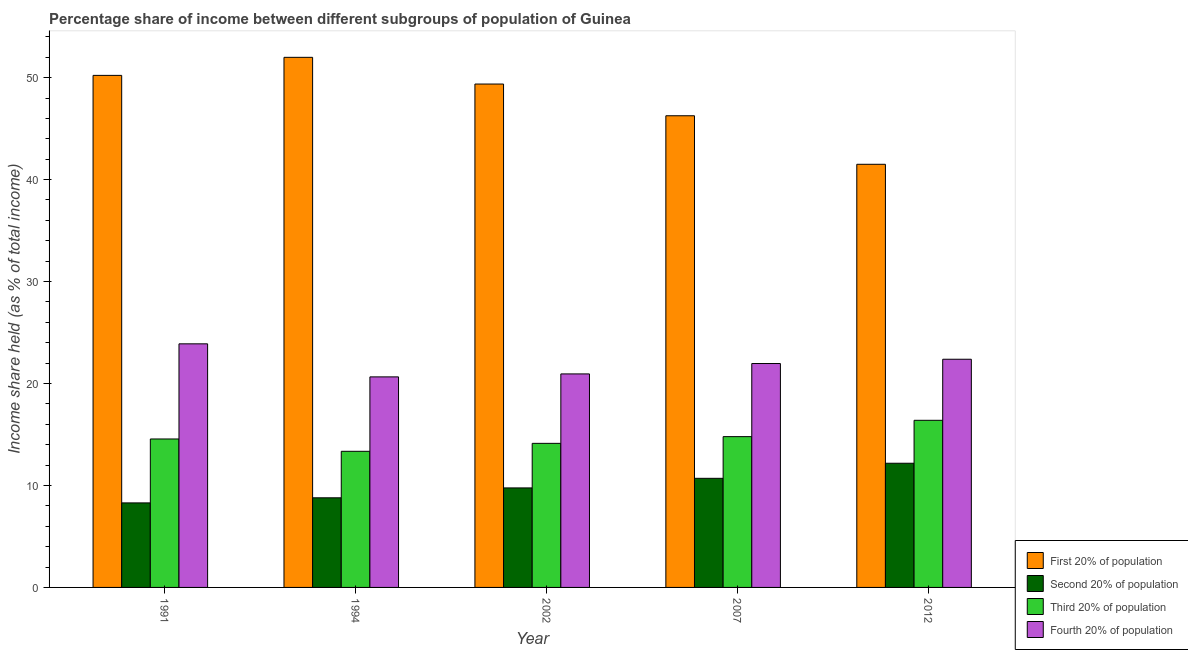How many groups of bars are there?
Provide a short and direct response. 5. Are the number of bars per tick equal to the number of legend labels?
Give a very brief answer. Yes. Are the number of bars on each tick of the X-axis equal?
Offer a terse response. Yes. How many bars are there on the 5th tick from the left?
Make the answer very short. 4. How many bars are there on the 3rd tick from the right?
Make the answer very short. 4. In how many cases, is the number of bars for a given year not equal to the number of legend labels?
Provide a short and direct response. 0. What is the share of the income held by third 20% of the population in 1994?
Provide a short and direct response. 13.35. Across all years, what is the maximum share of the income held by second 20% of the population?
Offer a very short reply. 12.18. Across all years, what is the minimum share of the income held by first 20% of the population?
Offer a terse response. 41.5. What is the total share of the income held by second 20% of the population in the graph?
Your answer should be compact. 49.72. What is the difference between the share of the income held by first 20% of the population in 1991 and that in 2007?
Your response must be concise. 3.96. What is the difference between the share of the income held by fourth 20% of the population in 2012 and the share of the income held by third 20% of the population in 2002?
Offer a terse response. 1.44. What is the average share of the income held by fourth 20% of the population per year?
Provide a short and direct response. 21.96. In how many years, is the share of the income held by first 20% of the population greater than 36 %?
Your answer should be compact. 5. What is the ratio of the share of the income held by fourth 20% of the population in 1994 to that in 2007?
Your response must be concise. 0.94. Is the share of the income held by first 20% of the population in 2002 less than that in 2012?
Make the answer very short. No. Is the difference between the share of the income held by first 20% of the population in 1994 and 2007 greater than the difference between the share of the income held by fourth 20% of the population in 1994 and 2007?
Give a very brief answer. No. What is the difference between the highest and the second highest share of the income held by second 20% of the population?
Ensure brevity in your answer.  1.48. What is the difference between the highest and the lowest share of the income held by fourth 20% of the population?
Make the answer very short. 3.24. Is it the case that in every year, the sum of the share of the income held by second 20% of the population and share of the income held by fourth 20% of the population is greater than the sum of share of the income held by first 20% of the population and share of the income held by third 20% of the population?
Offer a terse response. No. What does the 4th bar from the left in 1994 represents?
Keep it short and to the point. Fourth 20% of population. What does the 3rd bar from the right in 2002 represents?
Make the answer very short. Second 20% of population. How many years are there in the graph?
Ensure brevity in your answer.  5. What is the difference between two consecutive major ticks on the Y-axis?
Your answer should be very brief. 10. Are the values on the major ticks of Y-axis written in scientific E-notation?
Keep it short and to the point. No. Where does the legend appear in the graph?
Your response must be concise. Bottom right. How many legend labels are there?
Your answer should be very brief. 4. What is the title of the graph?
Give a very brief answer. Percentage share of income between different subgroups of population of Guinea. Does "HFC gas" appear as one of the legend labels in the graph?
Your answer should be very brief. No. What is the label or title of the X-axis?
Your answer should be very brief. Year. What is the label or title of the Y-axis?
Keep it short and to the point. Income share held (as % of total income). What is the Income share held (as % of total income) of First 20% of population in 1991?
Ensure brevity in your answer.  50.22. What is the Income share held (as % of total income) of Second 20% of population in 1991?
Keep it short and to the point. 8.29. What is the Income share held (as % of total income) of Third 20% of population in 1991?
Offer a terse response. 14.56. What is the Income share held (as % of total income) in Fourth 20% of population in 1991?
Your response must be concise. 23.89. What is the Income share held (as % of total income) in First 20% of population in 1994?
Offer a terse response. 51.99. What is the Income share held (as % of total income) in Second 20% of population in 1994?
Make the answer very short. 8.79. What is the Income share held (as % of total income) in Third 20% of population in 1994?
Ensure brevity in your answer.  13.35. What is the Income share held (as % of total income) in Fourth 20% of population in 1994?
Give a very brief answer. 20.65. What is the Income share held (as % of total income) of First 20% of population in 2002?
Ensure brevity in your answer.  49.37. What is the Income share held (as % of total income) of Second 20% of population in 2002?
Provide a short and direct response. 9.76. What is the Income share held (as % of total income) in Third 20% of population in 2002?
Ensure brevity in your answer.  14.13. What is the Income share held (as % of total income) in Fourth 20% of population in 2002?
Make the answer very short. 20.94. What is the Income share held (as % of total income) in First 20% of population in 2007?
Your response must be concise. 46.26. What is the Income share held (as % of total income) in Third 20% of population in 2007?
Provide a short and direct response. 14.79. What is the Income share held (as % of total income) of Fourth 20% of population in 2007?
Keep it short and to the point. 21.96. What is the Income share held (as % of total income) of First 20% of population in 2012?
Your response must be concise. 41.5. What is the Income share held (as % of total income) in Second 20% of population in 2012?
Your answer should be compact. 12.18. What is the Income share held (as % of total income) of Third 20% of population in 2012?
Your answer should be compact. 16.39. What is the Income share held (as % of total income) of Fourth 20% of population in 2012?
Ensure brevity in your answer.  22.38. Across all years, what is the maximum Income share held (as % of total income) of First 20% of population?
Keep it short and to the point. 51.99. Across all years, what is the maximum Income share held (as % of total income) in Second 20% of population?
Your answer should be compact. 12.18. Across all years, what is the maximum Income share held (as % of total income) in Third 20% of population?
Your answer should be very brief. 16.39. Across all years, what is the maximum Income share held (as % of total income) of Fourth 20% of population?
Your response must be concise. 23.89. Across all years, what is the minimum Income share held (as % of total income) in First 20% of population?
Your answer should be compact. 41.5. Across all years, what is the minimum Income share held (as % of total income) in Second 20% of population?
Ensure brevity in your answer.  8.29. Across all years, what is the minimum Income share held (as % of total income) of Third 20% of population?
Provide a short and direct response. 13.35. Across all years, what is the minimum Income share held (as % of total income) of Fourth 20% of population?
Make the answer very short. 20.65. What is the total Income share held (as % of total income) in First 20% of population in the graph?
Your answer should be compact. 239.34. What is the total Income share held (as % of total income) of Second 20% of population in the graph?
Your answer should be compact. 49.72. What is the total Income share held (as % of total income) of Third 20% of population in the graph?
Keep it short and to the point. 73.22. What is the total Income share held (as % of total income) of Fourth 20% of population in the graph?
Your response must be concise. 109.82. What is the difference between the Income share held (as % of total income) in First 20% of population in 1991 and that in 1994?
Make the answer very short. -1.77. What is the difference between the Income share held (as % of total income) in Third 20% of population in 1991 and that in 1994?
Keep it short and to the point. 1.21. What is the difference between the Income share held (as % of total income) in Fourth 20% of population in 1991 and that in 1994?
Your answer should be compact. 3.24. What is the difference between the Income share held (as % of total income) in Second 20% of population in 1991 and that in 2002?
Offer a terse response. -1.47. What is the difference between the Income share held (as % of total income) of Third 20% of population in 1991 and that in 2002?
Your answer should be compact. 0.43. What is the difference between the Income share held (as % of total income) in Fourth 20% of population in 1991 and that in 2002?
Provide a short and direct response. 2.95. What is the difference between the Income share held (as % of total income) of First 20% of population in 1991 and that in 2007?
Your answer should be compact. 3.96. What is the difference between the Income share held (as % of total income) of Second 20% of population in 1991 and that in 2007?
Provide a short and direct response. -2.41. What is the difference between the Income share held (as % of total income) in Third 20% of population in 1991 and that in 2007?
Make the answer very short. -0.23. What is the difference between the Income share held (as % of total income) of Fourth 20% of population in 1991 and that in 2007?
Give a very brief answer. 1.93. What is the difference between the Income share held (as % of total income) of First 20% of population in 1991 and that in 2012?
Your response must be concise. 8.72. What is the difference between the Income share held (as % of total income) of Second 20% of population in 1991 and that in 2012?
Your answer should be compact. -3.89. What is the difference between the Income share held (as % of total income) in Third 20% of population in 1991 and that in 2012?
Your answer should be very brief. -1.83. What is the difference between the Income share held (as % of total income) of Fourth 20% of population in 1991 and that in 2012?
Provide a succinct answer. 1.51. What is the difference between the Income share held (as % of total income) in First 20% of population in 1994 and that in 2002?
Provide a short and direct response. 2.62. What is the difference between the Income share held (as % of total income) in Second 20% of population in 1994 and that in 2002?
Your answer should be compact. -0.97. What is the difference between the Income share held (as % of total income) of Third 20% of population in 1994 and that in 2002?
Offer a very short reply. -0.78. What is the difference between the Income share held (as % of total income) of Fourth 20% of population in 1994 and that in 2002?
Your response must be concise. -0.29. What is the difference between the Income share held (as % of total income) in First 20% of population in 1994 and that in 2007?
Make the answer very short. 5.73. What is the difference between the Income share held (as % of total income) of Second 20% of population in 1994 and that in 2007?
Your answer should be compact. -1.91. What is the difference between the Income share held (as % of total income) in Third 20% of population in 1994 and that in 2007?
Your answer should be compact. -1.44. What is the difference between the Income share held (as % of total income) of Fourth 20% of population in 1994 and that in 2007?
Provide a succinct answer. -1.31. What is the difference between the Income share held (as % of total income) in First 20% of population in 1994 and that in 2012?
Offer a very short reply. 10.49. What is the difference between the Income share held (as % of total income) in Second 20% of population in 1994 and that in 2012?
Offer a very short reply. -3.39. What is the difference between the Income share held (as % of total income) of Third 20% of population in 1994 and that in 2012?
Keep it short and to the point. -3.04. What is the difference between the Income share held (as % of total income) of Fourth 20% of population in 1994 and that in 2012?
Your answer should be compact. -1.73. What is the difference between the Income share held (as % of total income) in First 20% of population in 2002 and that in 2007?
Offer a terse response. 3.11. What is the difference between the Income share held (as % of total income) of Second 20% of population in 2002 and that in 2007?
Ensure brevity in your answer.  -0.94. What is the difference between the Income share held (as % of total income) of Third 20% of population in 2002 and that in 2007?
Provide a short and direct response. -0.66. What is the difference between the Income share held (as % of total income) in Fourth 20% of population in 2002 and that in 2007?
Give a very brief answer. -1.02. What is the difference between the Income share held (as % of total income) of First 20% of population in 2002 and that in 2012?
Your answer should be compact. 7.87. What is the difference between the Income share held (as % of total income) of Second 20% of population in 2002 and that in 2012?
Offer a very short reply. -2.42. What is the difference between the Income share held (as % of total income) of Third 20% of population in 2002 and that in 2012?
Your answer should be compact. -2.26. What is the difference between the Income share held (as % of total income) of Fourth 20% of population in 2002 and that in 2012?
Provide a succinct answer. -1.44. What is the difference between the Income share held (as % of total income) in First 20% of population in 2007 and that in 2012?
Provide a succinct answer. 4.76. What is the difference between the Income share held (as % of total income) of Second 20% of population in 2007 and that in 2012?
Make the answer very short. -1.48. What is the difference between the Income share held (as % of total income) in Third 20% of population in 2007 and that in 2012?
Give a very brief answer. -1.6. What is the difference between the Income share held (as % of total income) of Fourth 20% of population in 2007 and that in 2012?
Make the answer very short. -0.42. What is the difference between the Income share held (as % of total income) of First 20% of population in 1991 and the Income share held (as % of total income) of Second 20% of population in 1994?
Keep it short and to the point. 41.43. What is the difference between the Income share held (as % of total income) in First 20% of population in 1991 and the Income share held (as % of total income) in Third 20% of population in 1994?
Make the answer very short. 36.87. What is the difference between the Income share held (as % of total income) of First 20% of population in 1991 and the Income share held (as % of total income) of Fourth 20% of population in 1994?
Provide a short and direct response. 29.57. What is the difference between the Income share held (as % of total income) of Second 20% of population in 1991 and the Income share held (as % of total income) of Third 20% of population in 1994?
Your answer should be compact. -5.06. What is the difference between the Income share held (as % of total income) in Second 20% of population in 1991 and the Income share held (as % of total income) in Fourth 20% of population in 1994?
Offer a terse response. -12.36. What is the difference between the Income share held (as % of total income) in Third 20% of population in 1991 and the Income share held (as % of total income) in Fourth 20% of population in 1994?
Your answer should be very brief. -6.09. What is the difference between the Income share held (as % of total income) in First 20% of population in 1991 and the Income share held (as % of total income) in Second 20% of population in 2002?
Your response must be concise. 40.46. What is the difference between the Income share held (as % of total income) in First 20% of population in 1991 and the Income share held (as % of total income) in Third 20% of population in 2002?
Offer a very short reply. 36.09. What is the difference between the Income share held (as % of total income) of First 20% of population in 1991 and the Income share held (as % of total income) of Fourth 20% of population in 2002?
Ensure brevity in your answer.  29.28. What is the difference between the Income share held (as % of total income) of Second 20% of population in 1991 and the Income share held (as % of total income) of Third 20% of population in 2002?
Offer a terse response. -5.84. What is the difference between the Income share held (as % of total income) in Second 20% of population in 1991 and the Income share held (as % of total income) in Fourth 20% of population in 2002?
Provide a short and direct response. -12.65. What is the difference between the Income share held (as % of total income) of Third 20% of population in 1991 and the Income share held (as % of total income) of Fourth 20% of population in 2002?
Offer a very short reply. -6.38. What is the difference between the Income share held (as % of total income) in First 20% of population in 1991 and the Income share held (as % of total income) in Second 20% of population in 2007?
Offer a terse response. 39.52. What is the difference between the Income share held (as % of total income) of First 20% of population in 1991 and the Income share held (as % of total income) of Third 20% of population in 2007?
Your answer should be very brief. 35.43. What is the difference between the Income share held (as % of total income) of First 20% of population in 1991 and the Income share held (as % of total income) of Fourth 20% of population in 2007?
Your answer should be compact. 28.26. What is the difference between the Income share held (as % of total income) of Second 20% of population in 1991 and the Income share held (as % of total income) of Fourth 20% of population in 2007?
Offer a very short reply. -13.67. What is the difference between the Income share held (as % of total income) of Third 20% of population in 1991 and the Income share held (as % of total income) of Fourth 20% of population in 2007?
Ensure brevity in your answer.  -7.4. What is the difference between the Income share held (as % of total income) in First 20% of population in 1991 and the Income share held (as % of total income) in Second 20% of population in 2012?
Make the answer very short. 38.04. What is the difference between the Income share held (as % of total income) in First 20% of population in 1991 and the Income share held (as % of total income) in Third 20% of population in 2012?
Keep it short and to the point. 33.83. What is the difference between the Income share held (as % of total income) of First 20% of population in 1991 and the Income share held (as % of total income) of Fourth 20% of population in 2012?
Give a very brief answer. 27.84. What is the difference between the Income share held (as % of total income) of Second 20% of population in 1991 and the Income share held (as % of total income) of Third 20% of population in 2012?
Ensure brevity in your answer.  -8.1. What is the difference between the Income share held (as % of total income) of Second 20% of population in 1991 and the Income share held (as % of total income) of Fourth 20% of population in 2012?
Keep it short and to the point. -14.09. What is the difference between the Income share held (as % of total income) in Third 20% of population in 1991 and the Income share held (as % of total income) in Fourth 20% of population in 2012?
Give a very brief answer. -7.82. What is the difference between the Income share held (as % of total income) in First 20% of population in 1994 and the Income share held (as % of total income) in Second 20% of population in 2002?
Keep it short and to the point. 42.23. What is the difference between the Income share held (as % of total income) in First 20% of population in 1994 and the Income share held (as % of total income) in Third 20% of population in 2002?
Your response must be concise. 37.86. What is the difference between the Income share held (as % of total income) in First 20% of population in 1994 and the Income share held (as % of total income) in Fourth 20% of population in 2002?
Your answer should be very brief. 31.05. What is the difference between the Income share held (as % of total income) in Second 20% of population in 1994 and the Income share held (as % of total income) in Third 20% of population in 2002?
Provide a succinct answer. -5.34. What is the difference between the Income share held (as % of total income) in Second 20% of population in 1994 and the Income share held (as % of total income) in Fourth 20% of population in 2002?
Offer a terse response. -12.15. What is the difference between the Income share held (as % of total income) of Third 20% of population in 1994 and the Income share held (as % of total income) of Fourth 20% of population in 2002?
Keep it short and to the point. -7.59. What is the difference between the Income share held (as % of total income) in First 20% of population in 1994 and the Income share held (as % of total income) in Second 20% of population in 2007?
Offer a terse response. 41.29. What is the difference between the Income share held (as % of total income) in First 20% of population in 1994 and the Income share held (as % of total income) in Third 20% of population in 2007?
Give a very brief answer. 37.2. What is the difference between the Income share held (as % of total income) in First 20% of population in 1994 and the Income share held (as % of total income) in Fourth 20% of population in 2007?
Your response must be concise. 30.03. What is the difference between the Income share held (as % of total income) in Second 20% of population in 1994 and the Income share held (as % of total income) in Fourth 20% of population in 2007?
Your answer should be compact. -13.17. What is the difference between the Income share held (as % of total income) in Third 20% of population in 1994 and the Income share held (as % of total income) in Fourth 20% of population in 2007?
Provide a short and direct response. -8.61. What is the difference between the Income share held (as % of total income) in First 20% of population in 1994 and the Income share held (as % of total income) in Second 20% of population in 2012?
Ensure brevity in your answer.  39.81. What is the difference between the Income share held (as % of total income) in First 20% of population in 1994 and the Income share held (as % of total income) in Third 20% of population in 2012?
Offer a terse response. 35.6. What is the difference between the Income share held (as % of total income) in First 20% of population in 1994 and the Income share held (as % of total income) in Fourth 20% of population in 2012?
Your answer should be very brief. 29.61. What is the difference between the Income share held (as % of total income) of Second 20% of population in 1994 and the Income share held (as % of total income) of Third 20% of population in 2012?
Keep it short and to the point. -7.6. What is the difference between the Income share held (as % of total income) of Second 20% of population in 1994 and the Income share held (as % of total income) of Fourth 20% of population in 2012?
Offer a very short reply. -13.59. What is the difference between the Income share held (as % of total income) in Third 20% of population in 1994 and the Income share held (as % of total income) in Fourth 20% of population in 2012?
Your answer should be very brief. -9.03. What is the difference between the Income share held (as % of total income) in First 20% of population in 2002 and the Income share held (as % of total income) in Second 20% of population in 2007?
Keep it short and to the point. 38.67. What is the difference between the Income share held (as % of total income) of First 20% of population in 2002 and the Income share held (as % of total income) of Third 20% of population in 2007?
Offer a very short reply. 34.58. What is the difference between the Income share held (as % of total income) of First 20% of population in 2002 and the Income share held (as % of total income) of Fourth 20% of population in 2007?
Offer a terse response. 27.41. What is the difference between the Income share held (as % of total income) of Second 20% of population in 2002 and the Income share held (as % of total income) of Third 20% of population in 2007?
Make the answer very short. -5.03. What is the difference between the Income share held (as % of total income) in Third 20% of population in 2002 and the Income share held (as % of total income) in Fourth 20% of population in 2007?
Offer a terse response. -7.83. What is the difference between the Income share held (as % of total income) of First 20% of population in 2002 and the Income share held (as % of total income) of Second 20% of population in 2012?
Offer a very short reply. 37.19. What is the difference between the Income share held (as % of total income) in First 20% of population in 2002 and the Income share held (as % of total income) in Third 20% of population in 2012?
Your answer should be compact. 32.98. What is the difference between the Income share held (as % of total income) of First 20% of population in 2002 and the Income share held (as % of total income) of Fourth 20% of population in 2012?
Provide a succinct answer. 26.99. What is the difference between the Income share held (as % of total income) of Second 20% of population in 2002 and the Income share held (as % of total income) of Third 20% of population in 2012?
Make the answer very short. -6.63. What is the difference between the Income share held (as % of total income) of Second 20% of population in 2002 and the Income share held (as % of total income) of Fourth 20% of population in 2012?
Provide a short and direct response. -12.62. What is the difference between the Income share held (as % of total income) of Third 20% of population in 2002 and the Income share held (as % of total income) of Fourth 20% of population in 2012?
Offer a terse response. -8.25. What is the difference between the Income share held (as % of total income) of First 20% of population in 2007 and the Income share held (as % of total income) of Second 20% of population in 2012?
Ensure brevity in your answer.  34.08. What is the difference between the Income share held (as % of total income) of First 20% of population in 2007 and the Income share held (as % of total income) of Third 20% of population in 2012?
Your response must be concise. 29.87. What is the difference between the Income share held (as % of total income) in First 20% of population in 2007 and the Income share held (as % of total income) in Fourth 20% of population in 2012?
Keep it short and to the point. 23.88. What is the difference between the Income share held (as % of total income) in Second 20% of population in 2007 and the Income share held (as % of total income) in Third 20% of population in 2012?
Provide a short and direct response. -5.69. What is the difference between the Income share held (as % of total income) of Second 20% of population in 2007 and the Income share held (as % of total income) of Fourth 20% of population in 2012?
Provide a short and direct response. -11.68. What is the difference between the Income share held (as % of total income) of Third 20% of population in 2007 and the Income share held (as % of total income) of Fourth 20% of population in 2012?
Make the answer very short. -7.59. What is the average Income share held (as % of total income) of First 20% of population per year?
Provide a succinct answer. 47.87. What is the average Income share held (as % of total income) of Second 20% of population per year?
Your response must be concise. 9.94. What is the average Income share held (as % of total income) of Third 20% of population per year?
Provide a short and direct response. 14.64. What is the average Income share held (as % of total income) of Fourth 20% of population per year?
Make the answer very short. 21.96. In the year 1991, what is the difference between the Income share held (as % of total income) in First 20% of population and Income share held (as % of total income) in Second 20% of population?
Your response must be concise. 41.93. In the year 1991, what is the difference between the Income share held (as % of total income) of First 20% of population and Income share held (as % of total income) of Third 20% of population?
Your answer should be compact. 35.66. In the year 1991, what is the difference between the Income share held (as % of total income) of First 20% of population and Income share held (as % of total income) of Fourth 20% of population?
Offer a terse response. 26.33. In the year 1991, what is the difference between the Income share held (as % of total income) in Second 20% of population and Income share held (as % of total income) in Third 20% of population?
Make the answer very short. -6.27. In the year 1991, what is the difference between the Income share held (as % of total income) of Second 20% of population and Income share held (as % of total income) of Fourth 20% of population?
Your answer should be compact. -15.6. In the year 1991, what is the difference between the Income share held (as % of total income) in Third 20% of population and Income share held (as % of total income) in Fourth 20% of population?
Offer a very short reply. -9.33. In the year 1994, what is the difference between the Income share held (as % of total income) in First 20% of population and Income share held (as % of total income) in Second 20% of population?
Make the answer very short. 43.2. In the year 1994, what is the difference between the Income share held (as % of total income) in First 20% of population and Income share held (as % of total income) in Third 20% of population?
Your response must be concise. 38.64. In the year 1994, what is the difference between the Income share held (as % of total income) in First 20% of population and Income share held (as % of total income) in Fourth 20% of population?
Your answer should be very brief. 31.34. In the year 1994, what is the difference between the Income share held (as % of total income) in Second 20% of population and Income share held (as % of total income) in Third 20% of population?
Your response must be concise. -4.56. In the year 1994, what is the difference between the Income share held (as % of total income) of Second 20% of population and Income share held (as % of total income) of Fourth 20% of population?
Give a very brief answer. -11.86. In the year 1994, what is the difference between the Income share held (as % of total income) in Third 20% of population and Income share held (as % of total income) in Fourth 20% of population?
Ensure brevity in your answer.  -7.3. In the year 2002, what is the difference between the Income share held (as % of total income) of First 20% of population and Income share held (as % of total income) of Second 20% of population?
Ensure brevity in your answer.  39.61. In the year 2002, what is the difference between the Income share held (as % of total income) of First 20% of population and Income share held (as % of total income) of Third 20% of population?
Make the answer very short. 35.24. In the year 2002, what is the difference between the Income share held (as % of total income) in First 20% of population and Income share held (as % of total income) in Fourth 20% of population?
Your response must be concise. 28.43. In the year 2002, what is the difference between the Income share held (as % of total income) in Second 20% of population and Income share held (as % of total income) in Third 20% of population?
Keep it short and to the point. -4.37. In the year 2002, what is the difference between the Income share held (as % of total income) of Second 20% of population and Income share held (as % of total income) of Fourth 20% of population?
Your response must be concise. -11.18. In the year 2002, what is the difference between the Income share held (as % of total income) of Third 20% of population and Income share held (as % of total income) of Fourth 20% of population?
Offer a very short reply. -6.81. In the year 2007, what is the difference between the Income share held (as % of total income) of First 20% of population and Income share held (as % of total income) of Second 20% of population?
Make the answer very short. 35.56. In the year 2007, what is the difference between the Income share held (as % of total income) of First 20% of population and Income share held (as % of total income) of Third 20% of population?
Your answer should be very brief. 31.47. In the year 2007, what is the difference between the Income share held (as % of total income) in First 20% of population and Income share held (as % of total income) in Fourth 20% of population?
Provide a succinct answer. 24.3. In the year 2007, what is the difference between the Income share held (as % of total income) of Second 20% of population and Income share held (as % of total income) of Third 20% of population?
Make the answer very short. -4.09. In the year 2007, what is the difference between the Income share held (as % of total income) of Second 20% of population and Income share held (as % of total income) of Fourth 20% of population?
Give a very brief answer. -11.26. In the year 2007, what is the difference between the Income share held (as % of total income) in Third 20% of population and Income share held (as % of total income) in Fourth 20% of population?
Give a very brief answer. -7.17. In the year 2012, what is the difference between the Income share held (as % of total income) of First 20% of population and Income share held (as % of total income) of Second 20% of population?
Ensure brevity in your answer.  29.32. In the year 2012, what is the difference between the Income share held (as % of total income) of First 20% of population and Income share held (as % of total income) of Third 20% of population?
Offer a terse response. 25.11. In the year 2012, what is the difference between the Income share held (as % of total income) in First 20% of population and Income share held (as % of total income) in Fourth 20% of population?
Give a very brief answer. 19.12. In the year 2012, what is the difference between the Income share held (as % of total income) in Second 20% of population and Income share held (as % of total income) in Third 20% of population?
Make the answer very short. -4.21. In the year 2012, what is the difference between the Income share held (as % of total income) in Third 20% of population and Income share held (as % of total income) in Fourth 20% of population?
Ensure brevity in your answer.  -5.99. What is the ratio of the Income share held (as % of total income) in First 20% of population in 1991 to that in 1994?
Your answer should be very brief. 0.97. What is the ratio of the Income share held (as % of total income) in Second 20% of population in 1991 to that in 1994?
Your answer should be compact. 0.94. What is the ratio of the Income share held (as % of total income) of Third 20% of population in 1991 to that in 1994?
Make the answer very short. 1.09. What is the ratio of the Income share held (as % of total income) in Fourth 20% of population in 1991 to that in 1994?
Keep it short and to the point. 1.16. What is the ratio of the Income share held (as % of total income) of First 20% of population in 1991 to that in 2002?
Offer a terse response. 1.02. What is the ratio of the Income share held (as % of total income) of Second 20% of population in 1991 to that in 2002?
Keep it short and to the point. 0.85. What is the ratio of the Income share held (as % of total income) in Third 20% of population in 1991 to that in 2002?
Keep it short and to the point. 1.03. What is the ratio of the Income share held (as % of total income) in Fourth 20% of population in 1991 to that in 2002?
Keep it short and to the point. 1.14. What is the ratio of the Income share held (as % of total income) of First 20% of population in 1991 to that in 2007?
Offer a very short reply. 1.09. What is the ratio of the Income share held (as % of total income) in Second 20% of population in 1991 to that in 2007?
Ensure brevity in your answer.  0.77. What is the ratio of the Income share held (as % of total income) in Third 20% of population in 1991 to that in 2007?
Ensure brevity in your answer.  0.98. What is the ratio of the Income share held (as % of total income) of Fourth 20% of population in 1991 to that in 2007?
Ensure brevity in your answer.  1.09. What is the ratio of the Income share held (as % of total income) in First 20% of population in 1991 to that in 2012?
Offer a terse response. 1.21. What is the ratio of the Income share held (as % of total income) of Second 20% of population in 1991 to that in 2012?
Give a very brief answer. 0.68. What is the ratio of the Income share held (as % of total income) in Third 20% of population in 1991 to that in 2012?
Keep it short and to the point. 0.89. What is the ratio of the Income share held (as % of total income) of Fourth 20% of population in 1991 to that in 2012?
Give a very brief answer. 1.07. What is the ratio of the Income share held (as % of total income) of First 20% of population in 1994 to that in 2002?
Offer a very short reply. 1.05. What is the ratio of the Income share held (as % of total income) of Second 20% of population in 1994 to that in 2002?
Offer a very short reply. 0.9. What is the ratio of the Income share held (as % of total income) in Third 20% of population in 1994 to that in 2002?
Ensure brevity in your answer.  0.94. What is the ratio of the Income share held (as % of total income) in Fourth 20% of population in 1994 to that in 2002?
Offer a very short reply. 0.99. What is the ratio of the Income share held (as % of total income) of First 20% of population in 1994 to that in 2007?
Provide a succinct answer. 1.12. What is the ratio of the Income share held (as % of total income) in Second 20% of population in 1994 to that in 2007?
Your answer should be compact. 0.82. What is the ratio of the Income share held (as % of total income) of Third 20% of population in 1994 to that in 2007?
Offer a very short reply. 0.9. What is the ratio of the Income share held (as % of total income) of Fourth 20% of population in 1994 to that in 2007?
Keep it short and to the point. 0.94. What is the ratio of the Income share held (as % of total income) in First 20% of population in 1994 to that in 2012?
Your response must be concise. 1.25. What is the ratio of the Income share held (as % of total income) of Second 20% of population in 1994 to that in 2012?
Ensure brevity in your answer.  0.72. What is the ratio of the Income share held (as % of total income) of Third 20% of population in 1994 to that in 2012?
Keep it short and to the point. 0.81. What is the ratio of the Income share held (as % of total income) in Fourth 20% of population in 1994 to that in 2012?
Offer a very short reply. 0.92. What is the ratio of the Income share held (as % of total income) in First 20% of population in 2002 to that in 2007?
Offer a terse response. 1.07. What is the ratio of the Income share held (as % of total income) in Second 20% of population in 2002 to that in 2007?
Offer a very short reply. 0.91. What is the ratio of the Income share held (as % of total income) in Third 20% of population in 2002 to that in 2007?
Your response must be concise. 0.96. What is the ratio of the Income share held (as % of total income) of Fourth 20% of population in 2002 to that in 2007?
Give a very brief answer. 0.95. What is the ratio of the Income share held (as % of total income) of First 20% of population in 2002 to that in 2012?
Your response must be concise. 1.19. What is the ratio of the Income share held (as % of total income) of Second 20% of population in 2002 to that in 2012?
Your answer should be compact. 0.8. What is the ratio of the Income share held (as % of total income) of Third 20% of population in 2002 to that in 2012?
Keep it short and to the point. 0.86. What is the ratio of the Income share held (as % of total income) of Fourth 20% of population in 2002 to that in 2012?
Ensure brevity in your answer.  0.94. What is the ratio of the Income share held (as % of total income) in First 20% of population in 2007 to that in 2012?
Offer a terse response. 1.11. What is the ratio of the Income share held (as % of total income) of Second 20% of population in 2007 to that in 2012?
Provide a short and direct response. 0.88. What is the ratio of the Income share held (as % of total income) of Third 20% of population in 2007 to that in 2012?
Make the answer very short. 0.9. What is the ratio of the Income share held (as % of total income) of Fourth 20% of population in 2007 to that in 2012?
Ensure brevity in your answer.  0.98. What is the difference between the highest and the second highest Income share held (as % of total income) of First 20% of population?
Offer a very short reply. 1.77. What is the difference between the highest and the second highest Income share held (as % of total income) of Second 20% of population?
Your response must be concise. 1.48. What is the difference between the highest and the second highest Income share held (as % of total income) of Fourth 20% of population?
Provide a succinct answer. 1.51. What is the difference between the highest and the lowest Income share held (as % of total income) in First 20% of population?
Your answer should be very brief. 10.49. What is the difference between the highest and the lowest Income share held (as % of total income) in Second 20% of population?
Your response must be concise. 3.89. What is the difference between the highest and the lowest Income share held (as % of total income) of Third 20% of population?
Your response must be concise. 3.04. What is the difference between the highest and the lowest Income share held (as % of total income) in Fourth 20% of population?
Offer a terse response. 3.24. 